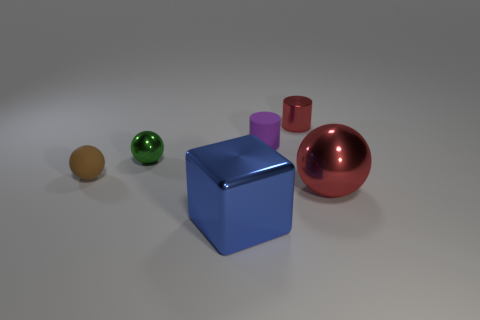Are there any other things that have the same size as the red metallic cylinder?
Make the answer very short. Yes. Is the size of the red metal cylinder the same as the brown ball?
Your answer should be compact. Yes. What number of brown things have the same material as the tiny green object?
Offer a terse response. 0. What is the size of the red object that is behind the small rubber thing on the right side of the green metal thing?
Provide a short and direct response. Small. The sphere that is both in front of the small green sphere and on the right side of the tiny brown matte thing is what color?
Offer a very short reply. Red. Is the shape of the purple thing the same as the brown rubber thing?
Ensure brevity in your answer.  No. The thing that is the same color as the small metallic cylinder is what size?
Make the answer very short. Large. There is a object that is on the right side of the shiny object that is behind the purple matte thing; what is its shape?
Your answer should be very brief. Sphere. Do the purple matte thing and the red shiny object that is in front of the purple rubber object have the same shape?
Offer a very short reply. No. What is the color of the metal ball that is the same size as the blue object?
Keep it short and to the point. Red. 